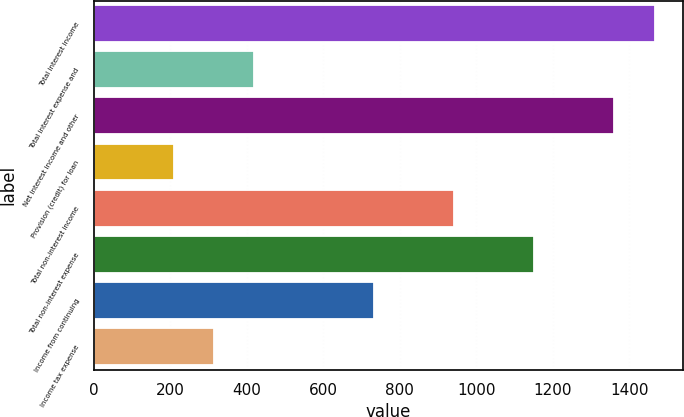Convert chart. <chart><loc_0><loc_0><loc_500><loc_500><bar_chart><fcel>Total interest income<fcel>Total interest expense and<fcel>Net interest income and other<fcel>Provision (credit) for loan<fcel>Total non-interest income<fcel>Total non-interest expense<fcel>Income from continuing<fcel>Income tax expense<nl><fcel>1465.68<fcel>419.03<fcel>1361.02<fcel>209.69<fcel>942.36<fcel>1151.69<fcel>733.03<fcel>314.36<nl></chart> 